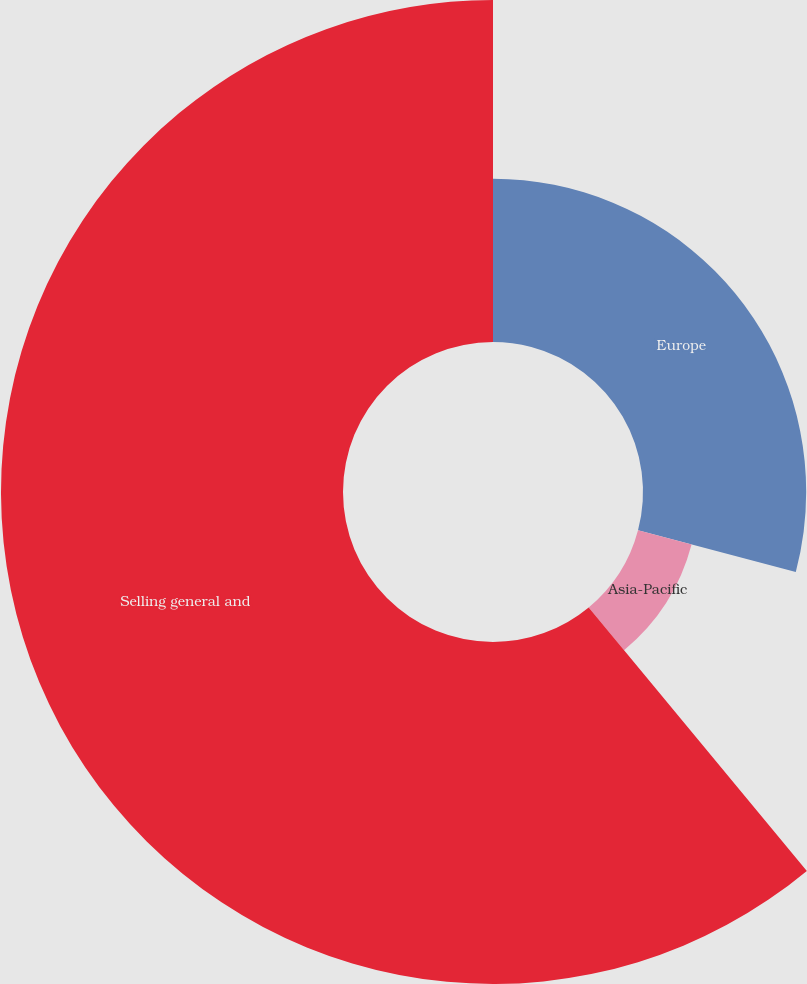Convert chart to OTSL. <chart><loc_0><loc_0><loc_500><loc_500><pie_chart><fcel>Europe<fcel>Asia-Pacific<fcel>Selling general and<nl><fcel>29.11%<fcel>9.88%<fcel>61.01%<nl></chart> 